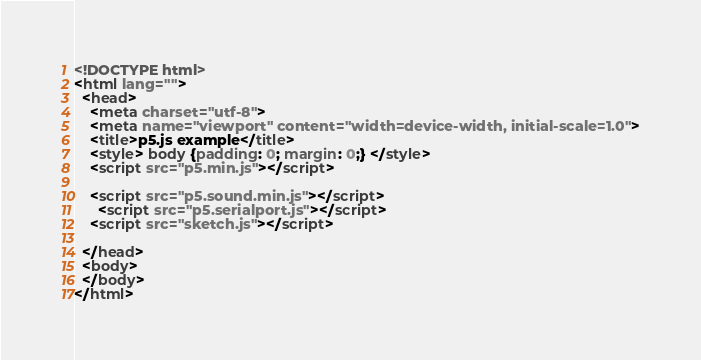<code> <loc_0><loc_0><loc_500><loc_500><_HTML_><!DOCTYPE html>
<html lang="">
  <head>
    <meta charset="utf-8">
    <meta name="viewport" content="width=device-width, initial-scale=1.0">
    <title>p5.js example</title>
    <style> body {padding: 0; margin: 0;} </style>
    <script src="p5.min.js"></script>
    
    <script src="p5.sound.min.js"></script>
      <script src="p5.serialport.js"></script>
    <script src="sketch.js"></script>
      
  </head>
  <body>
  </body>
</html>
</code> 